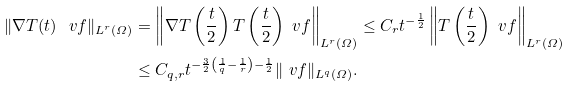Convert formula to latex. <formula><loc_0><loc_0><loc_500><loc_500>\| \nabla T ( t ) \ v f \| _ { L ^ { r } ( \varOmega ) } & = \left \| \nabla T \left ( \frac { t } { 2 } \right ) T \left ( \frac { t } { 2 } \right ) \ v f \right \| _ { L ^ { r } ( \varOmega ) } \leq C _ { r } t ^ { - \frac { 1 } { 2 } } \left \| T \left ( \frac { t } { 2 } \right ) \ v f \right \| _ { L ^ { r } ( \varOmega ) } \\ & \leq C _ { q , r } t ^ { - \frac { 3 } { 2 } \left ( \frac { 1 } { q } - \frac { 1 } { r } \right ) - \frac { 1 } { 2 } } \| \ v f \| _ { L ^ { q } ( \varOmega ) } .</formula> 